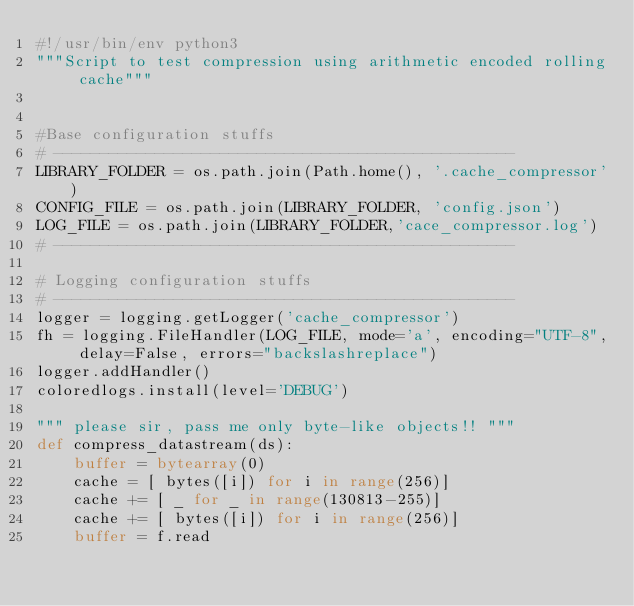Convert code to text. <code><loc_0><loc_0><loc_500><loc_500><_Python_>#!/usr/bin/env python3
"""Script to test compression using arithmetic encoded rolling cache"""


#Base configuration stuffs
# --------------------------------------------------
LIBRARY_FOLDER = os.path.join(Path.home(), '.cache_compressor')
CONFIG_FILE = os.path.join(LIBRARY_FOLDER, 'config.json')
LOG_FILE = os.path.join(LIBRARY_FOLDER,'cace_compressor.log')
# --------------------------------------------------

# Logging configuration stuffs
# --------------------------------------------------
logger = logging.getLogger('cache_compressor')
fh = logging.FileHandler(LOG_FILE, mode='a', encoding="UTF-8", delay=False, errors="backslashreplace")
logger.addHandler()
coloredlogs.install(level='DEBUG')

""" please sir, pass me only byte-like objects!! """
def compress_datastream(ds):
	buffer = bytearray(0)
	cache = [ bytes([i]) for i in range(256)]
	cache += [ _ for _ in range(130813-255)]
	cache += [ bytes([i]) for i in range(256)]
	buffer = f.read
</code> 